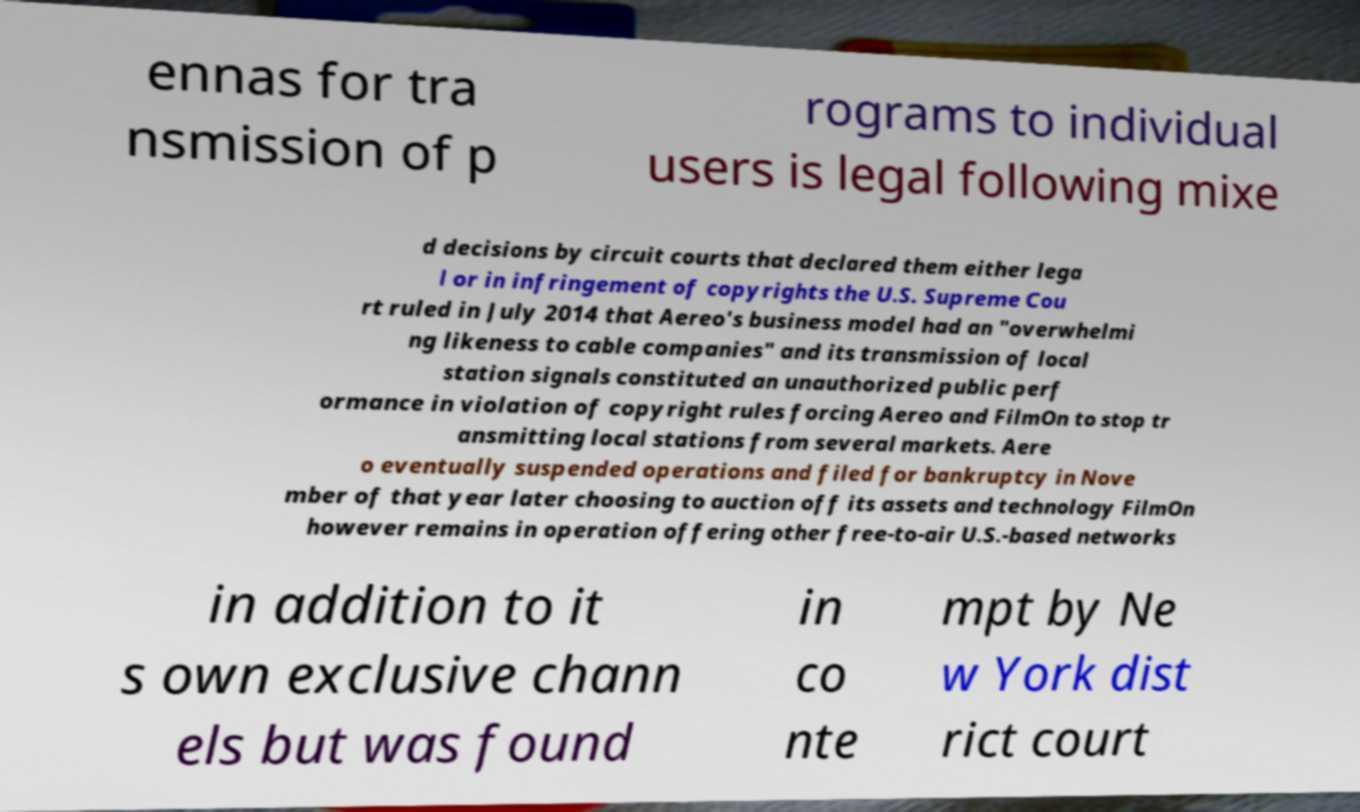Can you read and provide the text displayed in the image?This photo seems to have some interesting text. Can you extract and type it out for me? ennas for tra nsmission of p rograms to individual users is legal following mixe d decisions by circuit courts that declared them either lega l or in infringement of copyrights the U.S. Supreme Cou rt ruled in July 2014 that Aereo's business model had an "overwhelmi ng likeness to cable companies" and its transmission of local station signals constituted an unauthorized public perf ormance in violation of copyright rules forcing Aereo and FilmOn to stop tr ansmitting local stations from several markets. Aere o eventually suspended operations and filed for bankruptcy in Nove mber of that year later choosing to auction off its assets and technology FilmOn however remains in operation offering other free-to-air U.S.-based networks in addition to it s own exclusive chann els but was found in co nte mpt by Ne w York dist rict court 